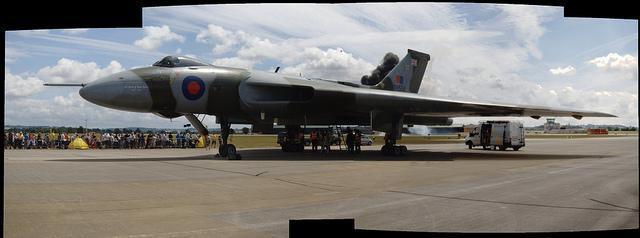How many people can be seen?
Give a very brief answer. 1. 